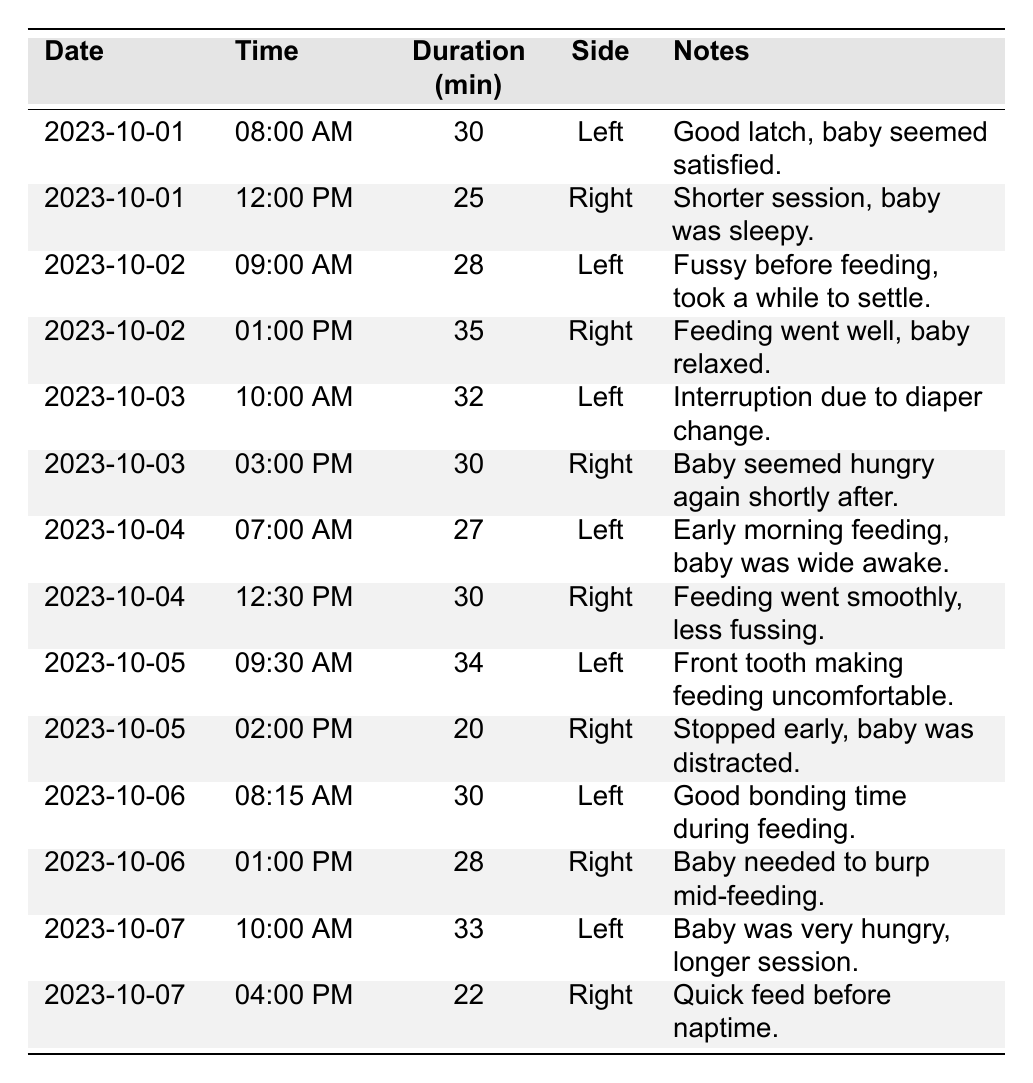What date had the longest breastfeeding session? The longest session is 35 minutes on October 2nd at 1:00 PM.
Answer: October 2nd How many sessions were recorded for each side? For the Left side, there are 7 sessions and for the Right side, there are 6 sessions.
Answer: Left: 7, Right: 6 What was the total duration of breastfeeding on October 5th? The durations on October 5th are 34 minutes and 20 minutes, so the total is 34 + 20 = 54 minutes.
Answer: 54 minutes Did the baby breastfeed more in the morning or the afternoon overall? The morning sessions total 2.5 hours (150 minutes) while the afternoon sessions total 1.5 hours (90 minutes), indicating more breastfeeding in the morning.
Answer: Morning What is the average duration of the breastfeeding sessions recorded? Sum of all durations is 30 + 25 + 28 + 35 + 32 + 30 + 27 + 30 + 34 + 20 + 30 + 28 + 33 + 22 =  510 minutes. With 14 sessions, the average duration is 510 / 14 ≈ 36.43 minutes.
Answer: Approximately 36.43 minutes On which day was there a note about the baby being fussy before feeding, and how long was that session? The note about being fussy is on October 2nd during the 9:00 AM session, which lasted 28 minutes.
Answer: October 2nd, 28 minutes What is the difference in session duration between the longest and shortest breastfeeding sessions? The longest session is 35 minutes and the shortest is 20 minutes, so the difference is 35 - 20 = 15 minutes.
Answer: 15 minutes Did any sessions report about the baby needing to burp? Yes, on October 6th at 1:00 PM, there was a note about the baby needing to burp mid-feeding.
Answer: Yes Which side was used for the session where the note mentions a good latch? The note about a good latch is for the Left side on October 1st at 8:00 AM.
Answer: Left What was the total number of feeding sessions logged? There are 14 feeding sessions recorded in total.
Answer: 14 sessions Was there ever a session where the baby felt satisfied according to the notes? Yes, on October 1st at 8:00 AM, the note says the baby seemed satisfied.
Answer: Yes 